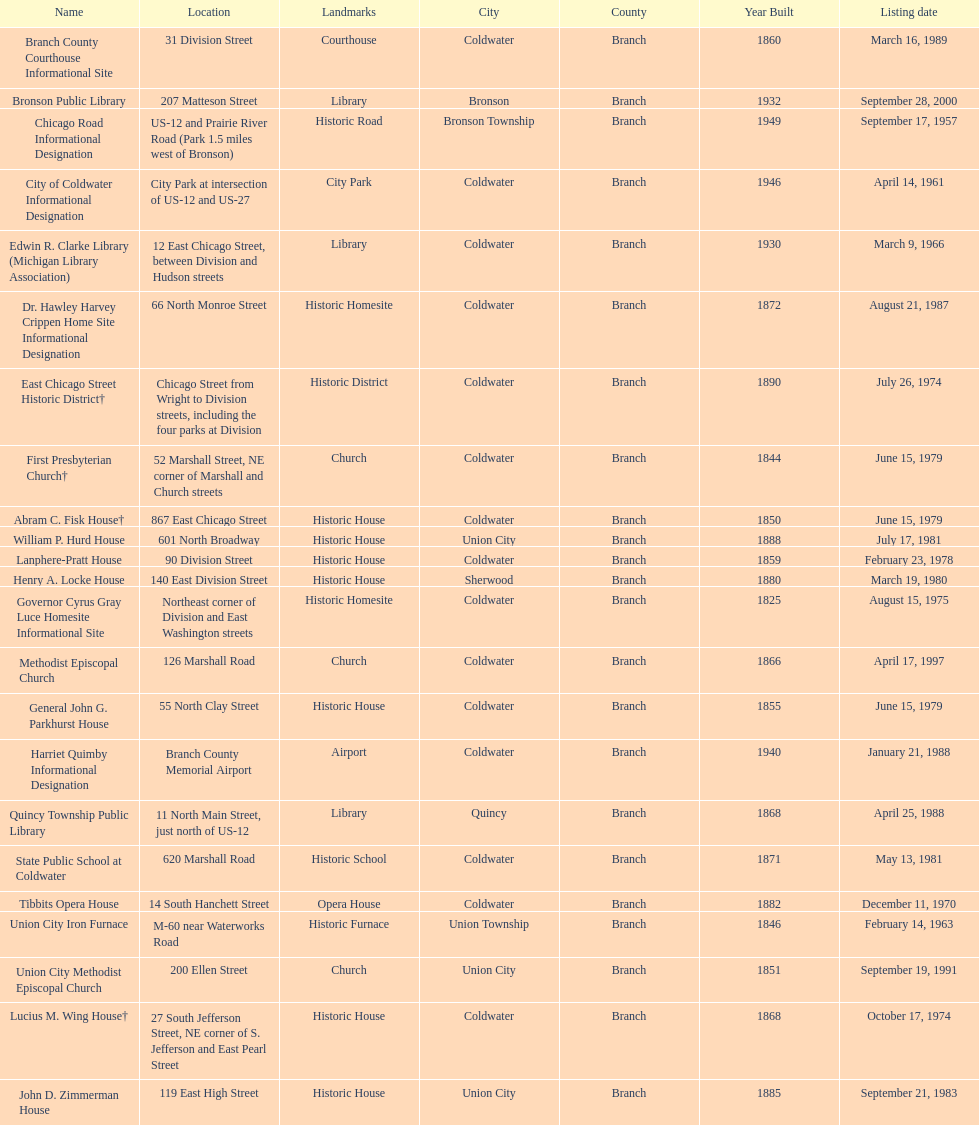How many years passed between the historic listing of public libraries in quincy and bronson? 12. 